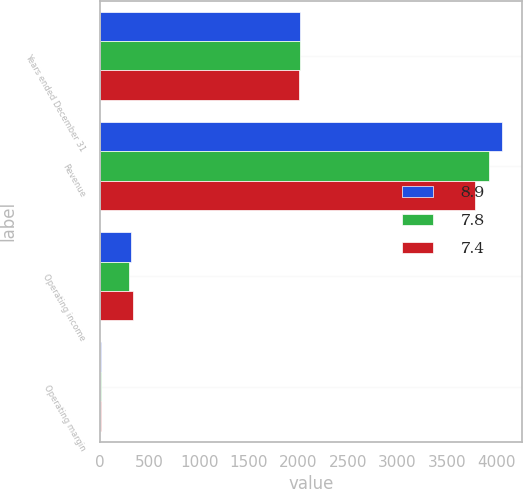Convert chart. <chart><loc_0><loc_0><loc_500><loc_500><stacked_bar_chart><ecel><fcel>Years ended December 31<fcel>Revenue<fcel>Operating income<fcel>Operating margin<nl><fcel>8.9<fcel>2013<fcel>4057<fcel>318<fcel>7.8<nl><fcel>7.8<fcel>2012<fcel>3925<fcel>289<fcel>7.4<nl><fcel>7.4<fcel>2011<fcel>3781<fcel>336<fcel>8.9<nl></chart> 